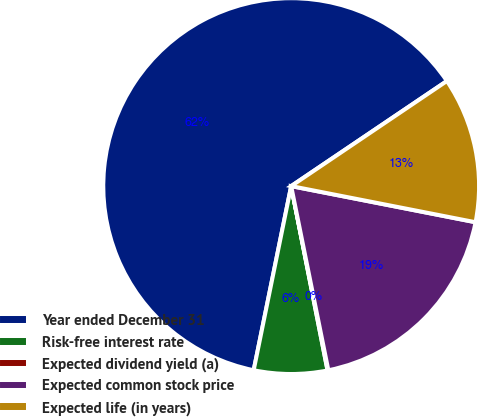Convert chart. <chart><loc_0><loc_0><loc_500><loc_500><pie_chart><fcel>Year ended December 31<fcel>Risk-free interest rate<fcel>Expected dividend yield (a)<fcel>Expected common stock price<fcel>Expected life (in years)<nl><fcel>62.36%<fcel>6.3%<fcel>0.07%<fcel>18.75%<fcel>12.53%<nl></chart> 